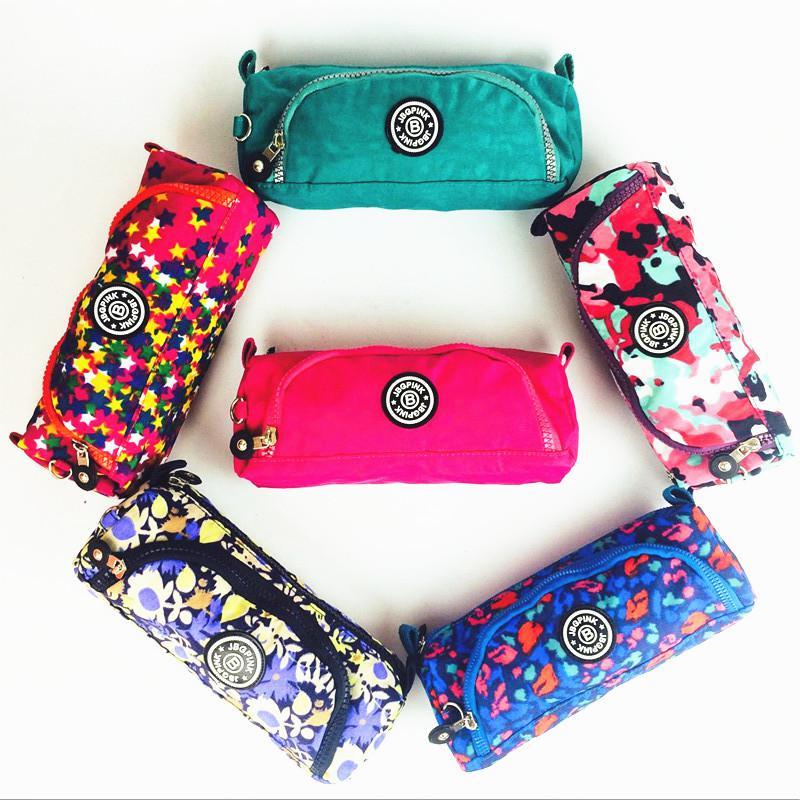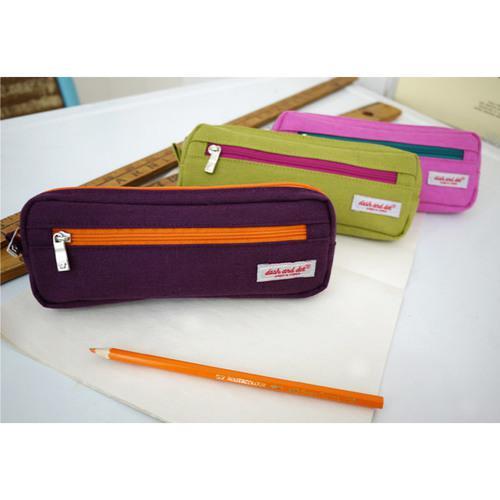The first image is the image on the left, the second image is the image on the right. Evaluate the accuracy of this statement regarding the images: "Both images have a pencil box that is flat.". Is it true? Answer yes or no. Yes. The first image is the image on the left, the second image is the image on the right. Considering the images on both sides, is "Each image contains a single closed pencil case, and at least one case is a solid color with contrasting zipper." valid? Answer yes or no. No. 